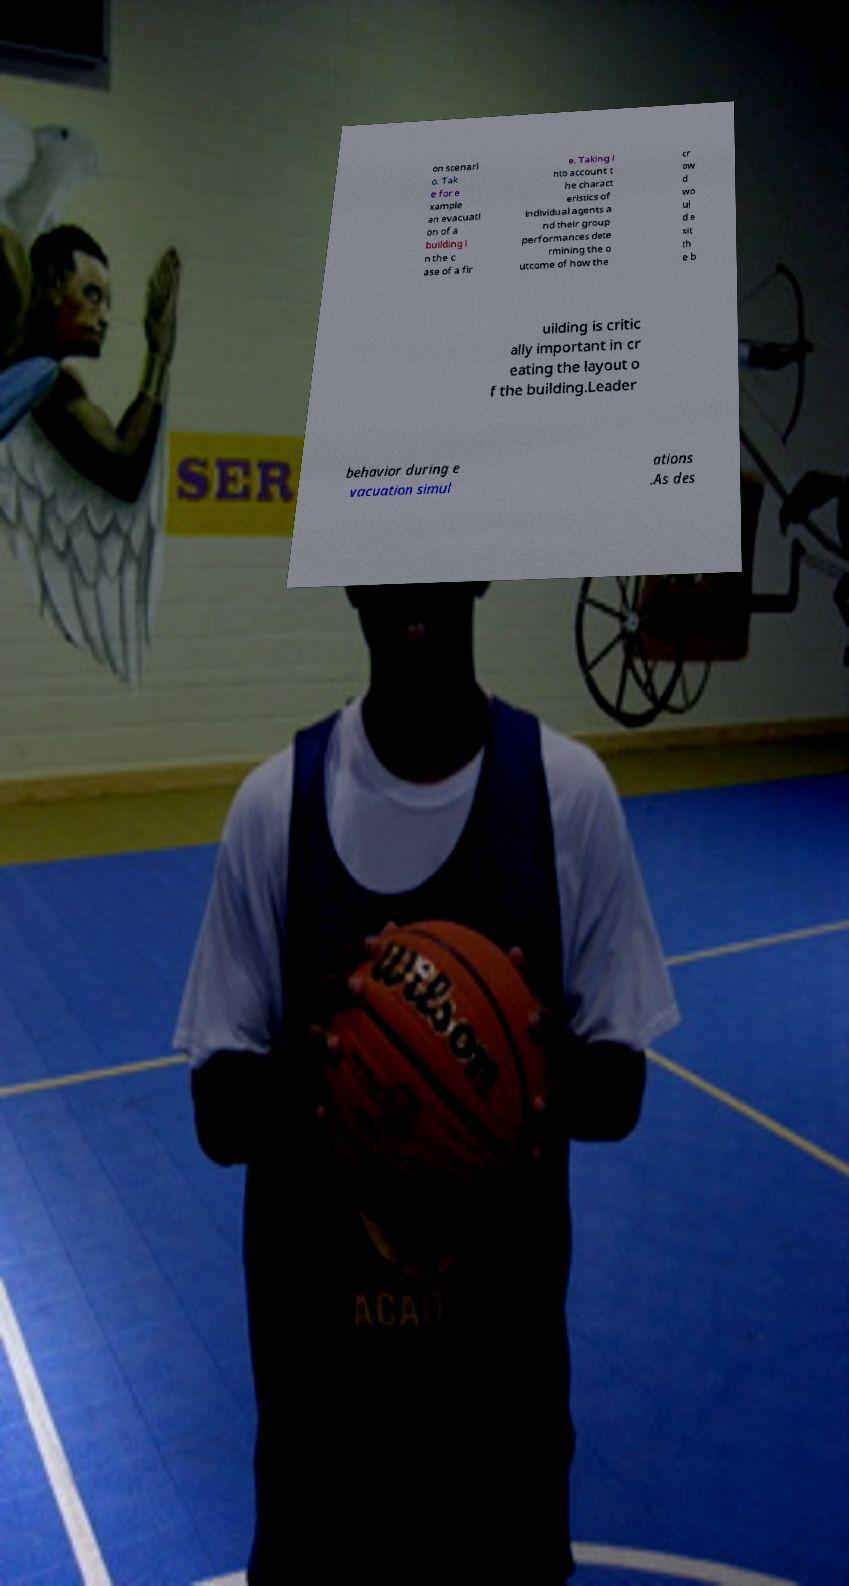There's text embedded in this image that I need extracted. Can you transcribe it verbatim? on scenari o. Tak e for e xample an evacuati on of a building i n the c ase of a fir e. Taking i nto account t he charact eristics of individual agents a nd their group performances dete rmining the o utcome of how the cr ow d wo ul d e xit th e b uilding is critic ally important in cr eating the layout o f the building.Leader behavior during e vacuation simul ations .As des 